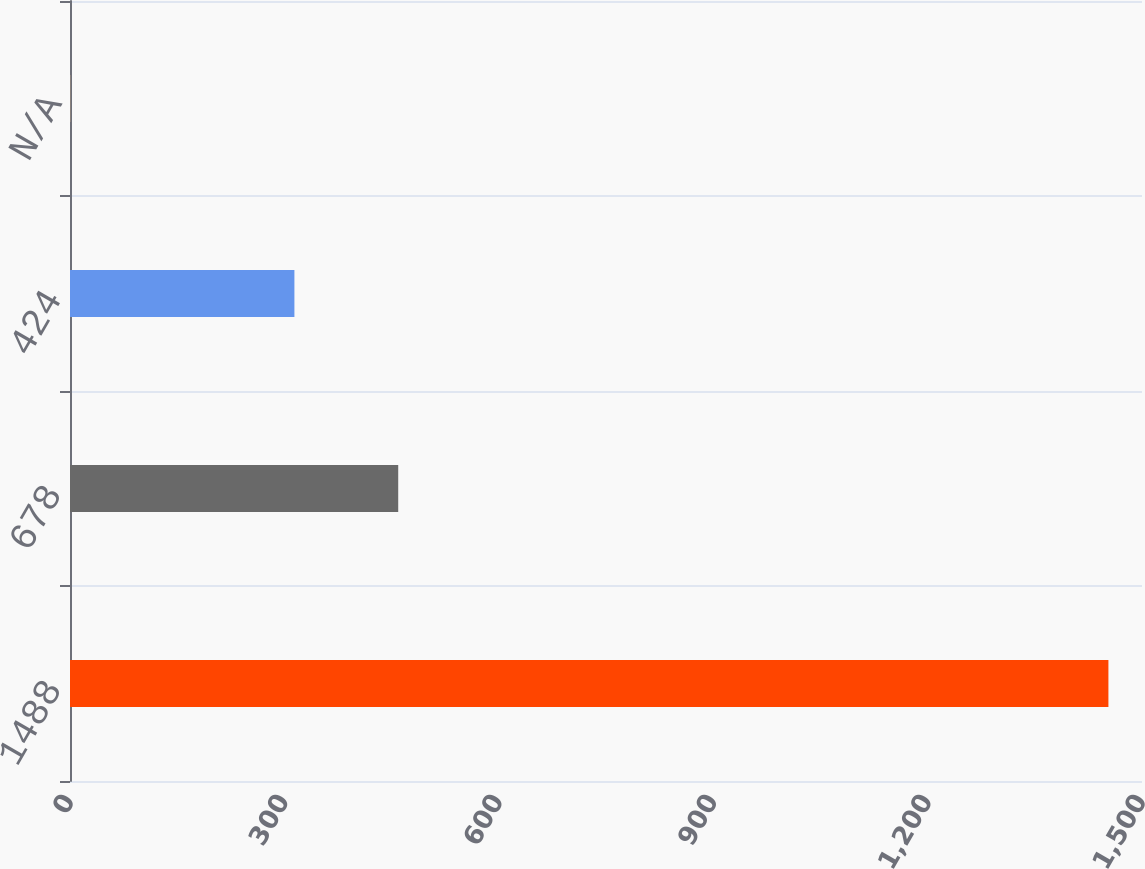<chart> <loc_0><loc_0><loc_500><loc_500><bar_chart><fcel>1488<fcel>678<fcel>424<fcel>N/A<nl><fcel>1453<fcel>459.26<fcel>314<fcel>0.39<nl></chart> 